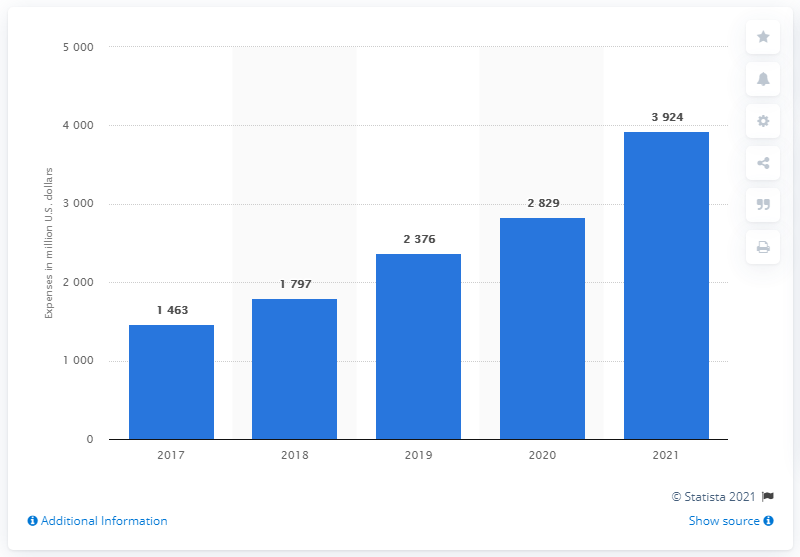Identify some key points in this picture. In 2021, Nvidia spent the most on research and development. 